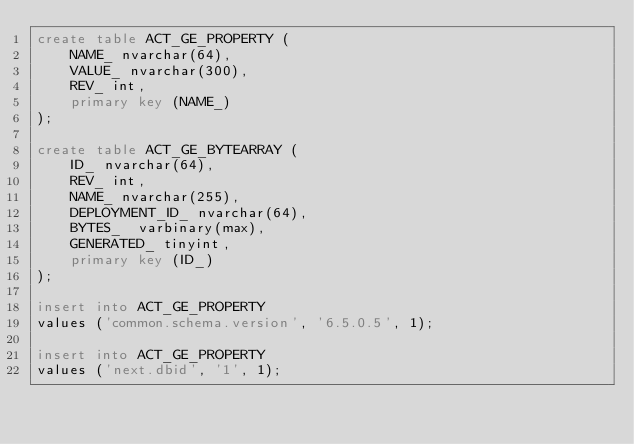Convert code to text. <code><loc_0><loc_0><loc_500><loc_500><_SQL_>create table ACT_GE_PROPERTY (
    NAME_ nvarchar(64),
    VALUE_ nvarchar(300),
    REV_ int,
    primary key (NAME_)
);

create table ACT_GE_BYTEARRAY (
    ID_ nvarchar(64),
    REV_ int,
    NAME_ nvarchar(255),
    DEPLOYMENT_ID_ nvarchar(64),
    BYTES_  varbinary(max),
    GENERATED_ tinyint,
    primary key (ID_)
);

insert into ACT_GE_PROPERTY
values ('common.schema.version', '6.5.0.5', 1);

insert into ACT_GE_PROPERTY
values ('next.dbid', '1', 1);
</code> 